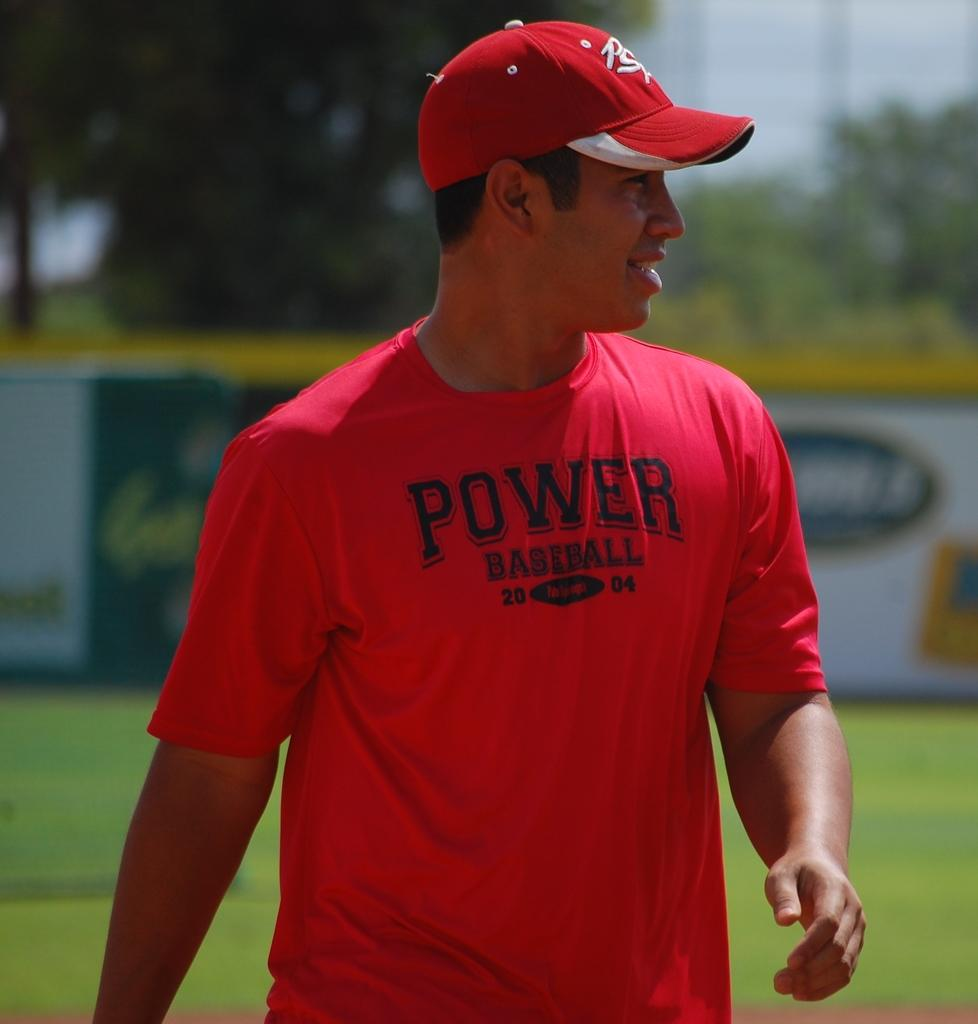<image>
Create a compact narrative representing the image presented. A man wears a red t-shirt printed with Power Baseball. 